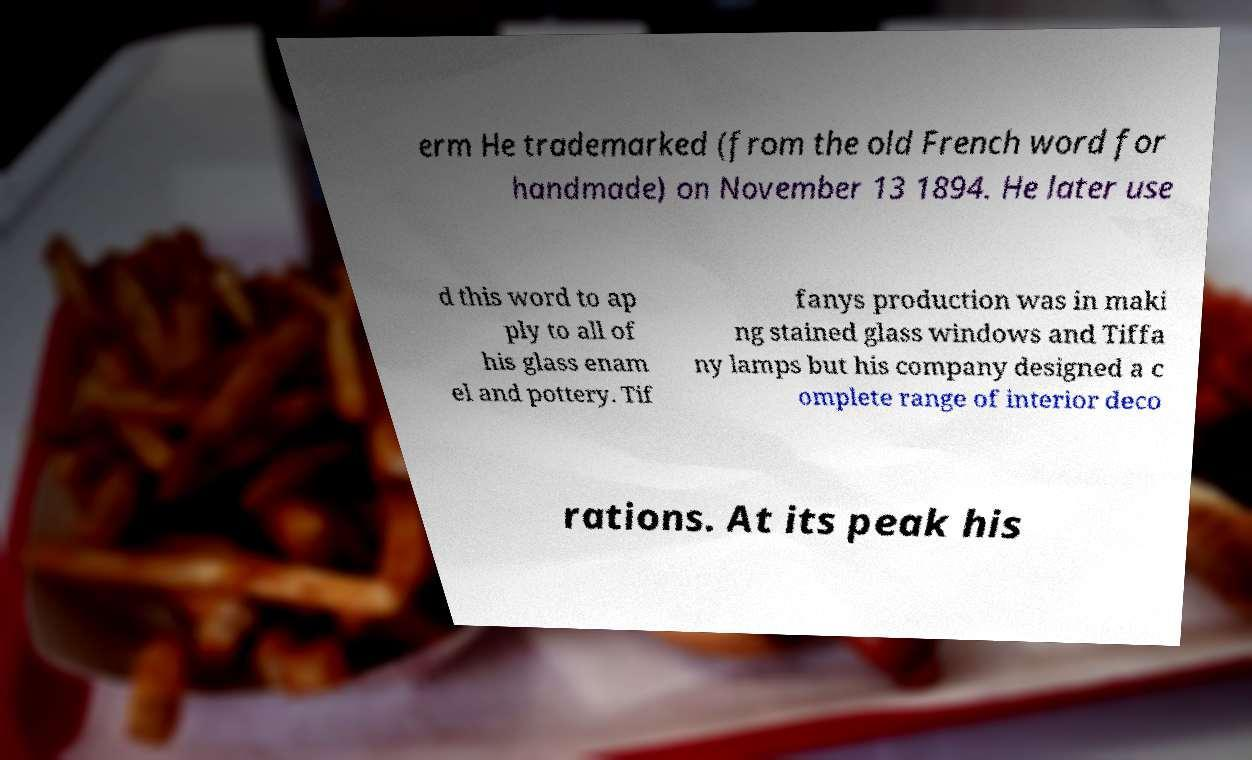Please identify and transcribe the text found in this image. erm He trademarked (from the old French word for handmade) on November 13 1894. He later use d this word to ap ply to all of his glass enam el and pottery. Tif fanys production was in maki ng stained glass windows and Tiffa ny lamps but his company designed a c omplete range of interior deco rations. At its peak his 